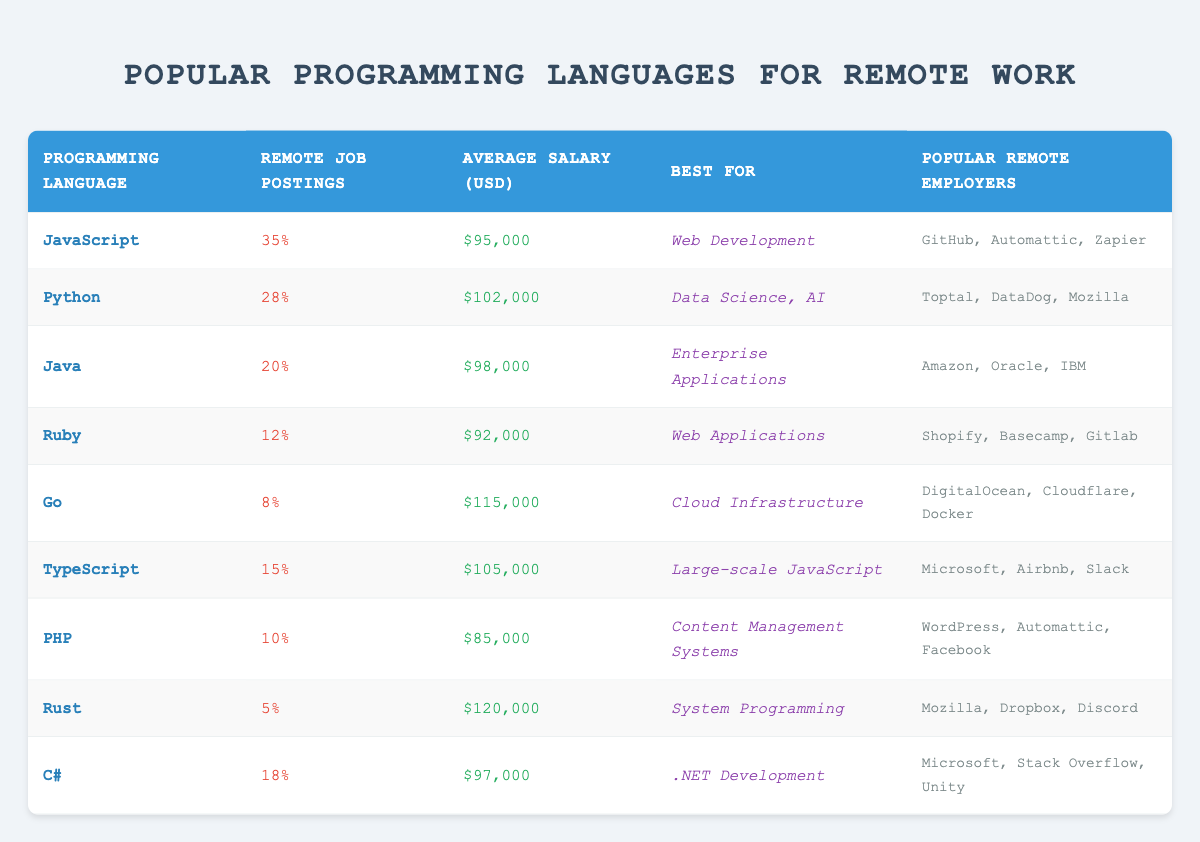What programming language has the highest percentage of remote job postings? Looking at the "Remote Job Postings" column, JavaScript has the highest percentage at 35%.
Answer: JavaScript Which programming language offers the highest average salary? The "Average Salary (USD)" column indicates Rust has the highest average salary at $120,000.
Answer: Rust Is Python considered best for web development? The table states Python is best for Data Science and AI, not web development. Therefore, the answer is no.
Answer: No What is the average salary for programming languages with less than 10% remote job postings? The programming languages with less than 10% postings are Go, PHP, and Rust. Their average salaries are $115,000, $85,000, and $120,000 respectively. The sum is $115,000 + $85,000 + $120,000 = $320,000. Dividing by 3 gives an average of $106,667.
Answer: $106,667 Which language is most commonly used for content management systems? The table indicates PHP is best known for content management systems.
Answer: PHP How many programming languages have an average salary above $100,000? Observing the "Average Salary (USD)" column, the languages with salaries above $100,000 are Python ($102,000), Go ($115,000), TypeScript ($105,000), and Rust ($120,000). This adds up to a total of 4 programming languages.
Answer: 4 Is there a programming language that is best for both web development and system programming? According to the table, JavaScript is best for web development and Rust is best for system programming. There is no programming language that serves both purposes.
Answer: No Calculate the difference in average salary between Go and PHP. The average salary for Go is $115,000 and for PHP it is $85,000. The difference is $115,000 - $85,000 = $30,000.
Answer: $30,000 Which programming language has more remote job postings: C# or Java? C# has 18% remote job postings and Java has 20%. Since Java has a higher percentage, it is the one with more postings.
Answer: Java 